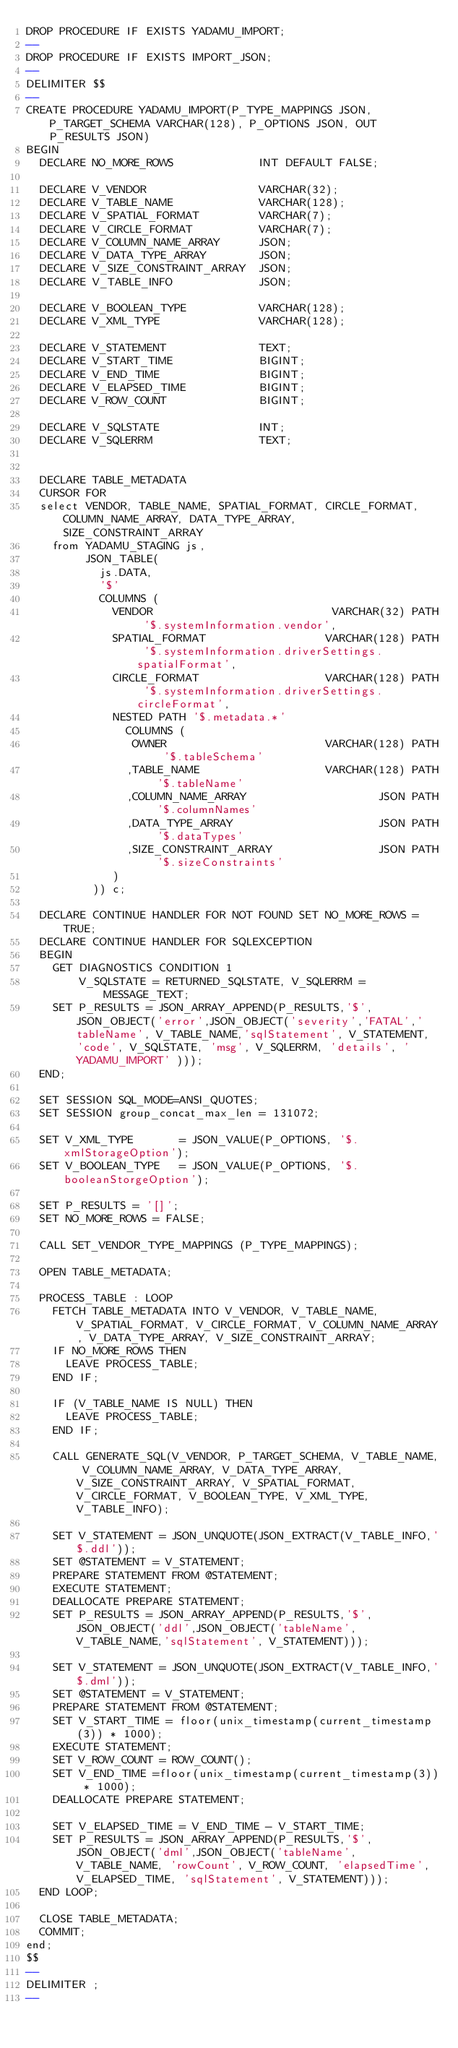Convert code to text. <code><loc_0><loc_0><loc_500><loc_500><_SQL_>DROP PROCEDURE IF EXISTS YADAMU_IMPORT;
--
DROP PROCEDURE IF EXISTS IMPORT_JSON;
--
DELIMITER $$
--
CREATE PROCEDURE YADAMU_IMPORT(P_TYPE_MAPPINGS JSON, P_TARGET_SCHEMA VARCHAR(128), P_OPTIONS JSON, OUT P_RESULTS JSON) 
BEGIN
  DECLARE NO_MORE_ROWS             INT DEFAULT FALSE;
  
  DECLARE V_VENDOR                 VARCHAR(32);
  DECLARE V_TABLE_NAME             VARCHAR(128);
  DECLARE V_SPATIAL_FORMAT         VARCHAR(7);
  DECLARE V_CIRCLE_FORMAT          VARCHAR(7);
  DECLARE V_COLUMN_NAME_ARRAY      JSON;
  DECLARE V_DATA_TYPE_ARRAY        JSON;
  DECLARE V_SIZE_CONSTRAINT_ARRAY  JSON;
  DECLARE V_TABLE_INFO             JSON;
  
  DECLARE V_BOOLEAN_TYPE           VARCHAR(128);
  DECLARE V_XML_TYPE               VARCHAR(128);
  
  DECLARE V_STATEMENT              TEXT;
  DECLARE V_START_TIME             BIGINT;
  DECLARE V_END_TIME               BIGINT;
  DECLARE V_ELAPSED_TIME           BIGINT;
  DECLARE V_ROW_COUNT              BIGINT;
  
  DECLARE V_SQLSTATE               INT;
  DECLARE V_SQLERRM                TEXT;
  
 
  DECLARE TABLE_METADATA 
  CURSOR FOR 
  select VENDOR, TABLE_NAME, SPATIAL_FORMAT, CIRCLE_FORMAT, COLUMN_NAME_ARRAY, DATA_TYPE_ARRAY, SIZE_CONSTRAINT_ARRAY
    from YADAMU_STAGING js,
         JSON_TABLE(
           js.DATA,
           '$'
           COLUMNS (
             VENDOR                           VARCHAR(32) PATH '$.systemInformation.vendor',
             SPATIAL_FORMAT                  VARCHAR(128) PATH '$.systemInformation.driverSettings.spatialFormat',
             CIRCLE_FORMAT                   VARCHAR(128) PATH '$.systemInformation.driverSettings.circleFormat',
             NESTED PATH '$.metadata.*' 
               COLUMNS (
                OWNER                        VARCHAR(128) PATH '$.tableSchema'
               ,TABLE_NAME                   VARCHAR(128) PATH '$.tableName'
               ,COLUMN_NAME_ARRAY                    JSON PATH '$.columnNames'
               ,DATA_TYPE_ARRAY                      JSON PATH '$.dataTypes'
               ,SIZE_CONSTRAINT_ARRAY                JSON PATH '$.sizeConstraints'
             )
          )) c;

  DECLARE CONTINUE HANDLER FOR NOT FOUND SET NO_MORE_ROWS = TRUE;
  DECLARE CONTINUE HANDLER FOR SQLEXCEPTION
  BEGIN 
    GET DIAGNOSTICS CONDITION 1
        V_SQLSTATE = RETURNED_SQLSTATE, V_SQLERRM = MESSAGE_TEXT;
    SET P_RESULTS = JSON_ARRAY_APPEND(P_RESULTS,'$',JSON_OBJECT('error',JSON_OBJECT('severity','FATAL','tableName', V_TABLE_NAME,'sqlStatement', V_STATEMENT, 'code', V_SQLSTATE, 'msg', V_SQLERRM, 'details', 'YADAMU_IMPORT' )));
  END;  

  SET SESSION SQL_MODE=ANSI_QUOTES;
  SET SESSION group_concat_max_len = 131072;
 
  SET V_XML_TYPE       = JSON_VALUE(P_OPTIONS, '$.xmlStorageOption');
  SET V_BOOLEAN_TYPE   = JSON_VALUE(P_OPTIONS, '$.booleanStorgeOption');
  
  SET P_RESULTS = '[]';
  SET NO_MORE_ROWS = FALSE;
   
  CALL SET_VENDOR_TYPE_MAPPINGS (P_TYPE_MAPPINGS);
  
  OPEN TABLE_METADATA;
    
  PROCESS_TABLE : LOOP
    FETCH TABLE_METADATA INTO V_VENDOR, V_TABLE_NAME, V_SPATIAL_FORMAT, V_CIRCLE_FORMAT, V_COLUMN_NAME_ARRAY, V_DATA_TYPE_ARRAY, V_SIZE_CONSTRAINT_ARRAY;
    IF NO_MORE_ROWS THEN
      LEAVE PROCESS_TABLE;
    END IF;
    
    IF (V_TABLE_NAME IS NULL) THEN
      LEAVE PROCESS_TABLE;
    END IF; 
    
    CALL GENERATE_SQL(V_VENDOR, P_TARGET_SCHEMA, V_TABLE_NAME, V_COLUMN_NAME_ARRAY, V_DATA_TYPE_ARRAY, V_SIZE_CONSTRAINT_ARRAY, V_SPATIAL_FORMAT, V_CIRCLE_FORMAT, V_BOOLEAN_TYPE, V_XML_TYPE, V_TABLE_INFO);
        
    SET V_STATEMENT = JSON_UNQUOTE(JSON_EXTRACT(V_TABLE_INFO,'$.ddl'));
    SET @STATEMENT = V_STATEMENT;
    PREPARE STATEMENT FROM @STATEMENT;
    EXECUTE STATEMENT;
    DEALLOCATE PREPARE STATEMENT;
    SET P_RESULTS = JSON_ARRAY_APPEND(P_RESULTS,'$',JSON_OBJECT('ddl',JSON_OBJECT('tableName', V_TABLE_NAME,'sqlStatement', V_STATEMENT)));
    
    SET V_STATEMENT = JSON_UNQUOTE(JSON_EXTRACT(V_TABLE_INFO,'$.dml'));
    SET @STATEMENT = V_STATEMENT;
    PREPARE STATEMENT FROM @STATEMENT;
    SET V_START_TIME = floor(unix_timestamp(current_timestamp(3)) * 1000);
    EXECUTE STATEMENT;
    SET V_ROW_COUNT = ROW_COUNT();
    SET V_END_TIME =floor(unix_timestamp(current_timestamp(3)) * 1000);
    DEALLOCATE PREPARE STATEMENT;
   
    SET V_ELAPSED_TIME = V_END_TIME - V_START_TIME;
    SET P_RESULTS = JSON_ARRAY_APPEND(P_RESULTS,'$',JSON_OBJECT('dml',JSON_OBJECT('tableName', V_TABLE_NAME, 'rowCount', V_ROW_COUNT, 'elapsedTime',V_ELAPSED_TIME, 'sqlStatement', V_STATEMENT)));
  END LOOP;
 
  CLOSE TABLE_METADATA;
  COMMIT;
end;
$$
--
DELIMITER ;
--</code> 